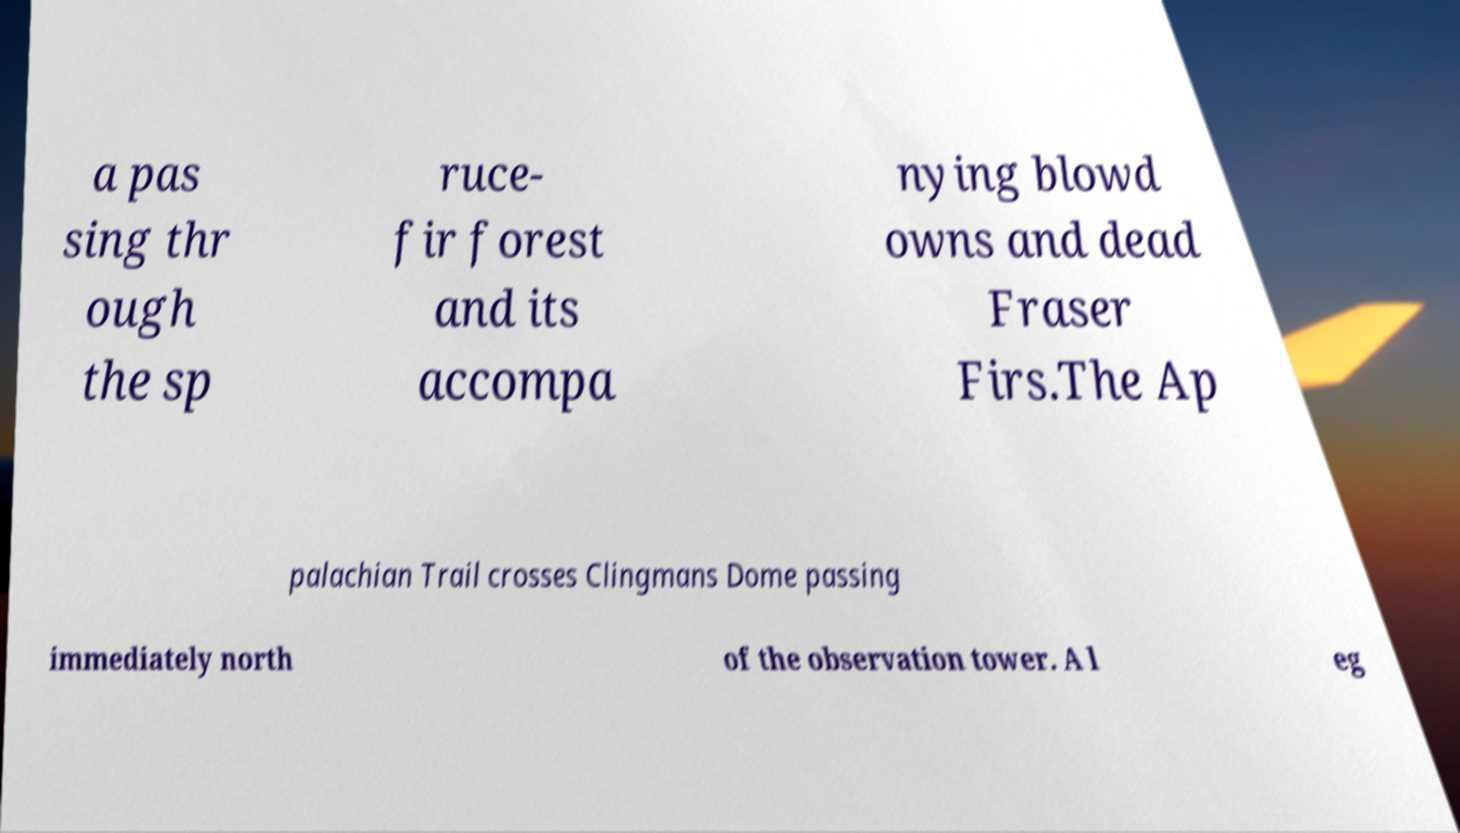Could you extract and type out the text from this image? a pas sing thr ough the sp ruce- fir forest and its accompa nying blowd owns and dead Fraser Firs.The Ap palachian Trail crosses Clingmans Dome passing immediately north of the observation tower. A l eg 